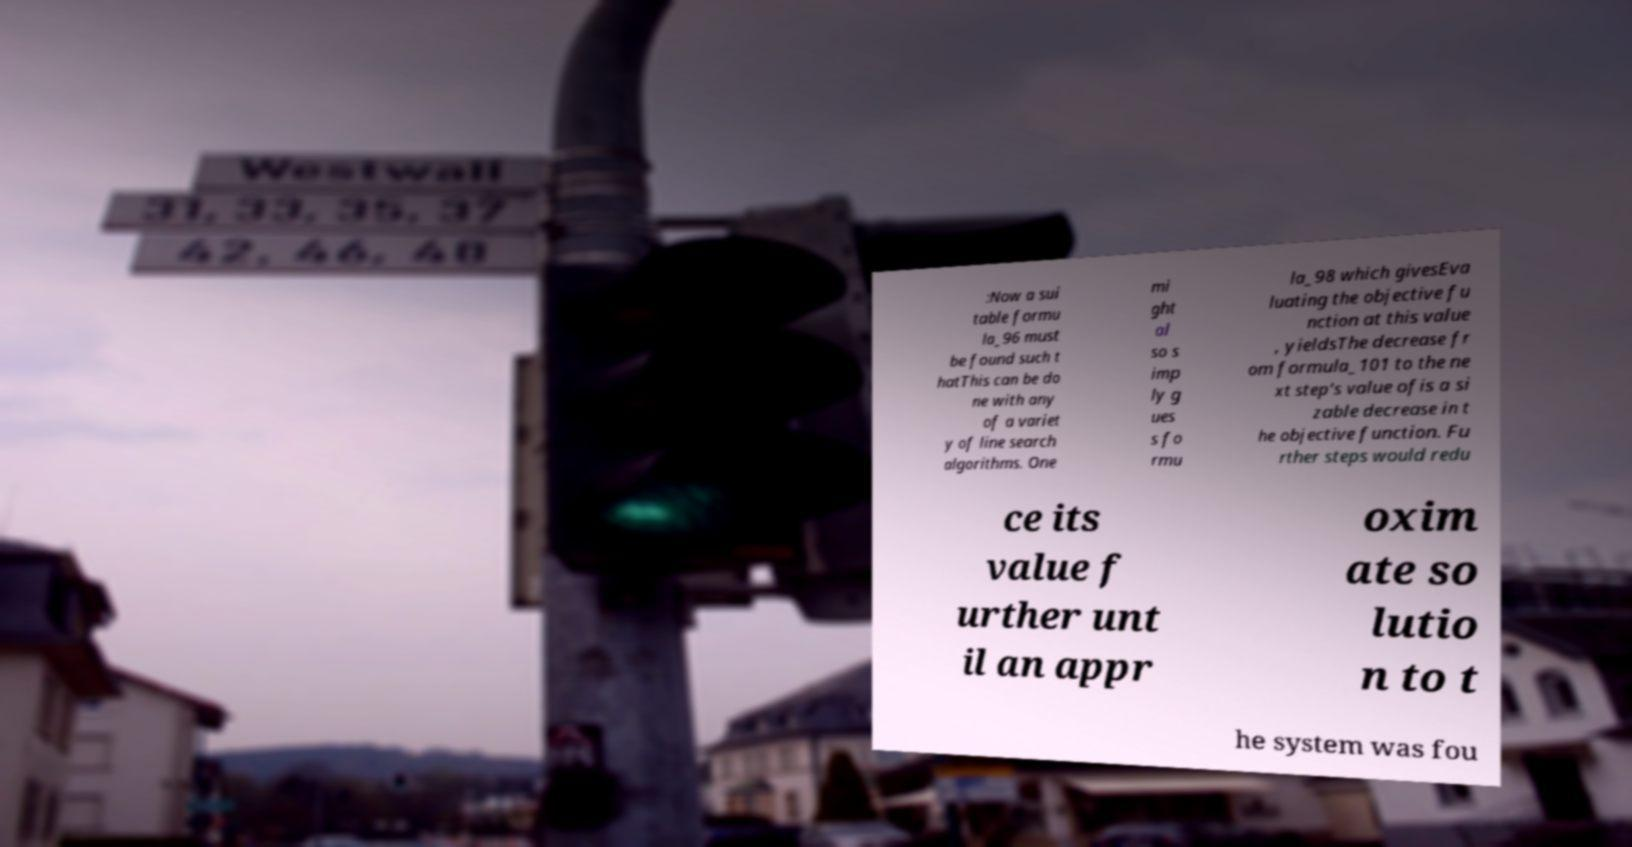I need the written content from this picture converted into text. Can you do that? :Now a sui table formu la_96 must be found such t hatThis can be do ne with any of a variet y of line search algorithms. One mi ght al so s imp ly g ues s fo rmu la_98 which givesEva luating the objective fu nction at this value , yieldsThe decrease fr om formula_101 to the ne xt step's value ofis a si zable decrease in t he objective function. Fu rther steps would redu ce its value f urther unt il an appr oxim ate so lutio n to t he system was fou 